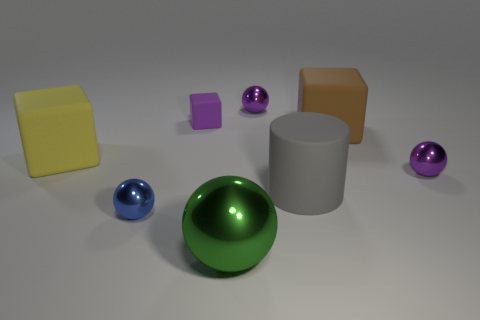Add 1 big red metal spheres. How many objects exist? 9 Subtract all cubes. How many objects are left? 5 Add 8 gray cylinders. How many gray cylinders are left? 9 Add 3 red rubber cubes. How many red rubber cubes exist? 3 Subtract 0 brown spheres. How many objects are left? 8 Subtract all big green shiny objects. Subtract all gray cylinders. How many objects are left? 6 